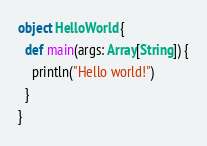<code> <loc_0><loc_0><loc_500><loc_500><_Scala_>object HelloWorld {
  def main(args: Array[String]) {
    println("Hello world!")
  }
}
</code> 